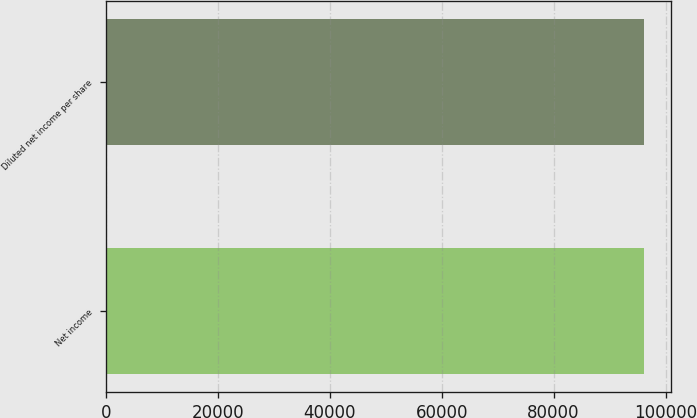Convert chart to OTSL. <chart><loc_0><loc_0><loc_500><loc_500><bar_chart><fcel>Net income<fcel>Diluted net income per share<nl><fcel>96241<fcel>96241.1<nl></chart> 